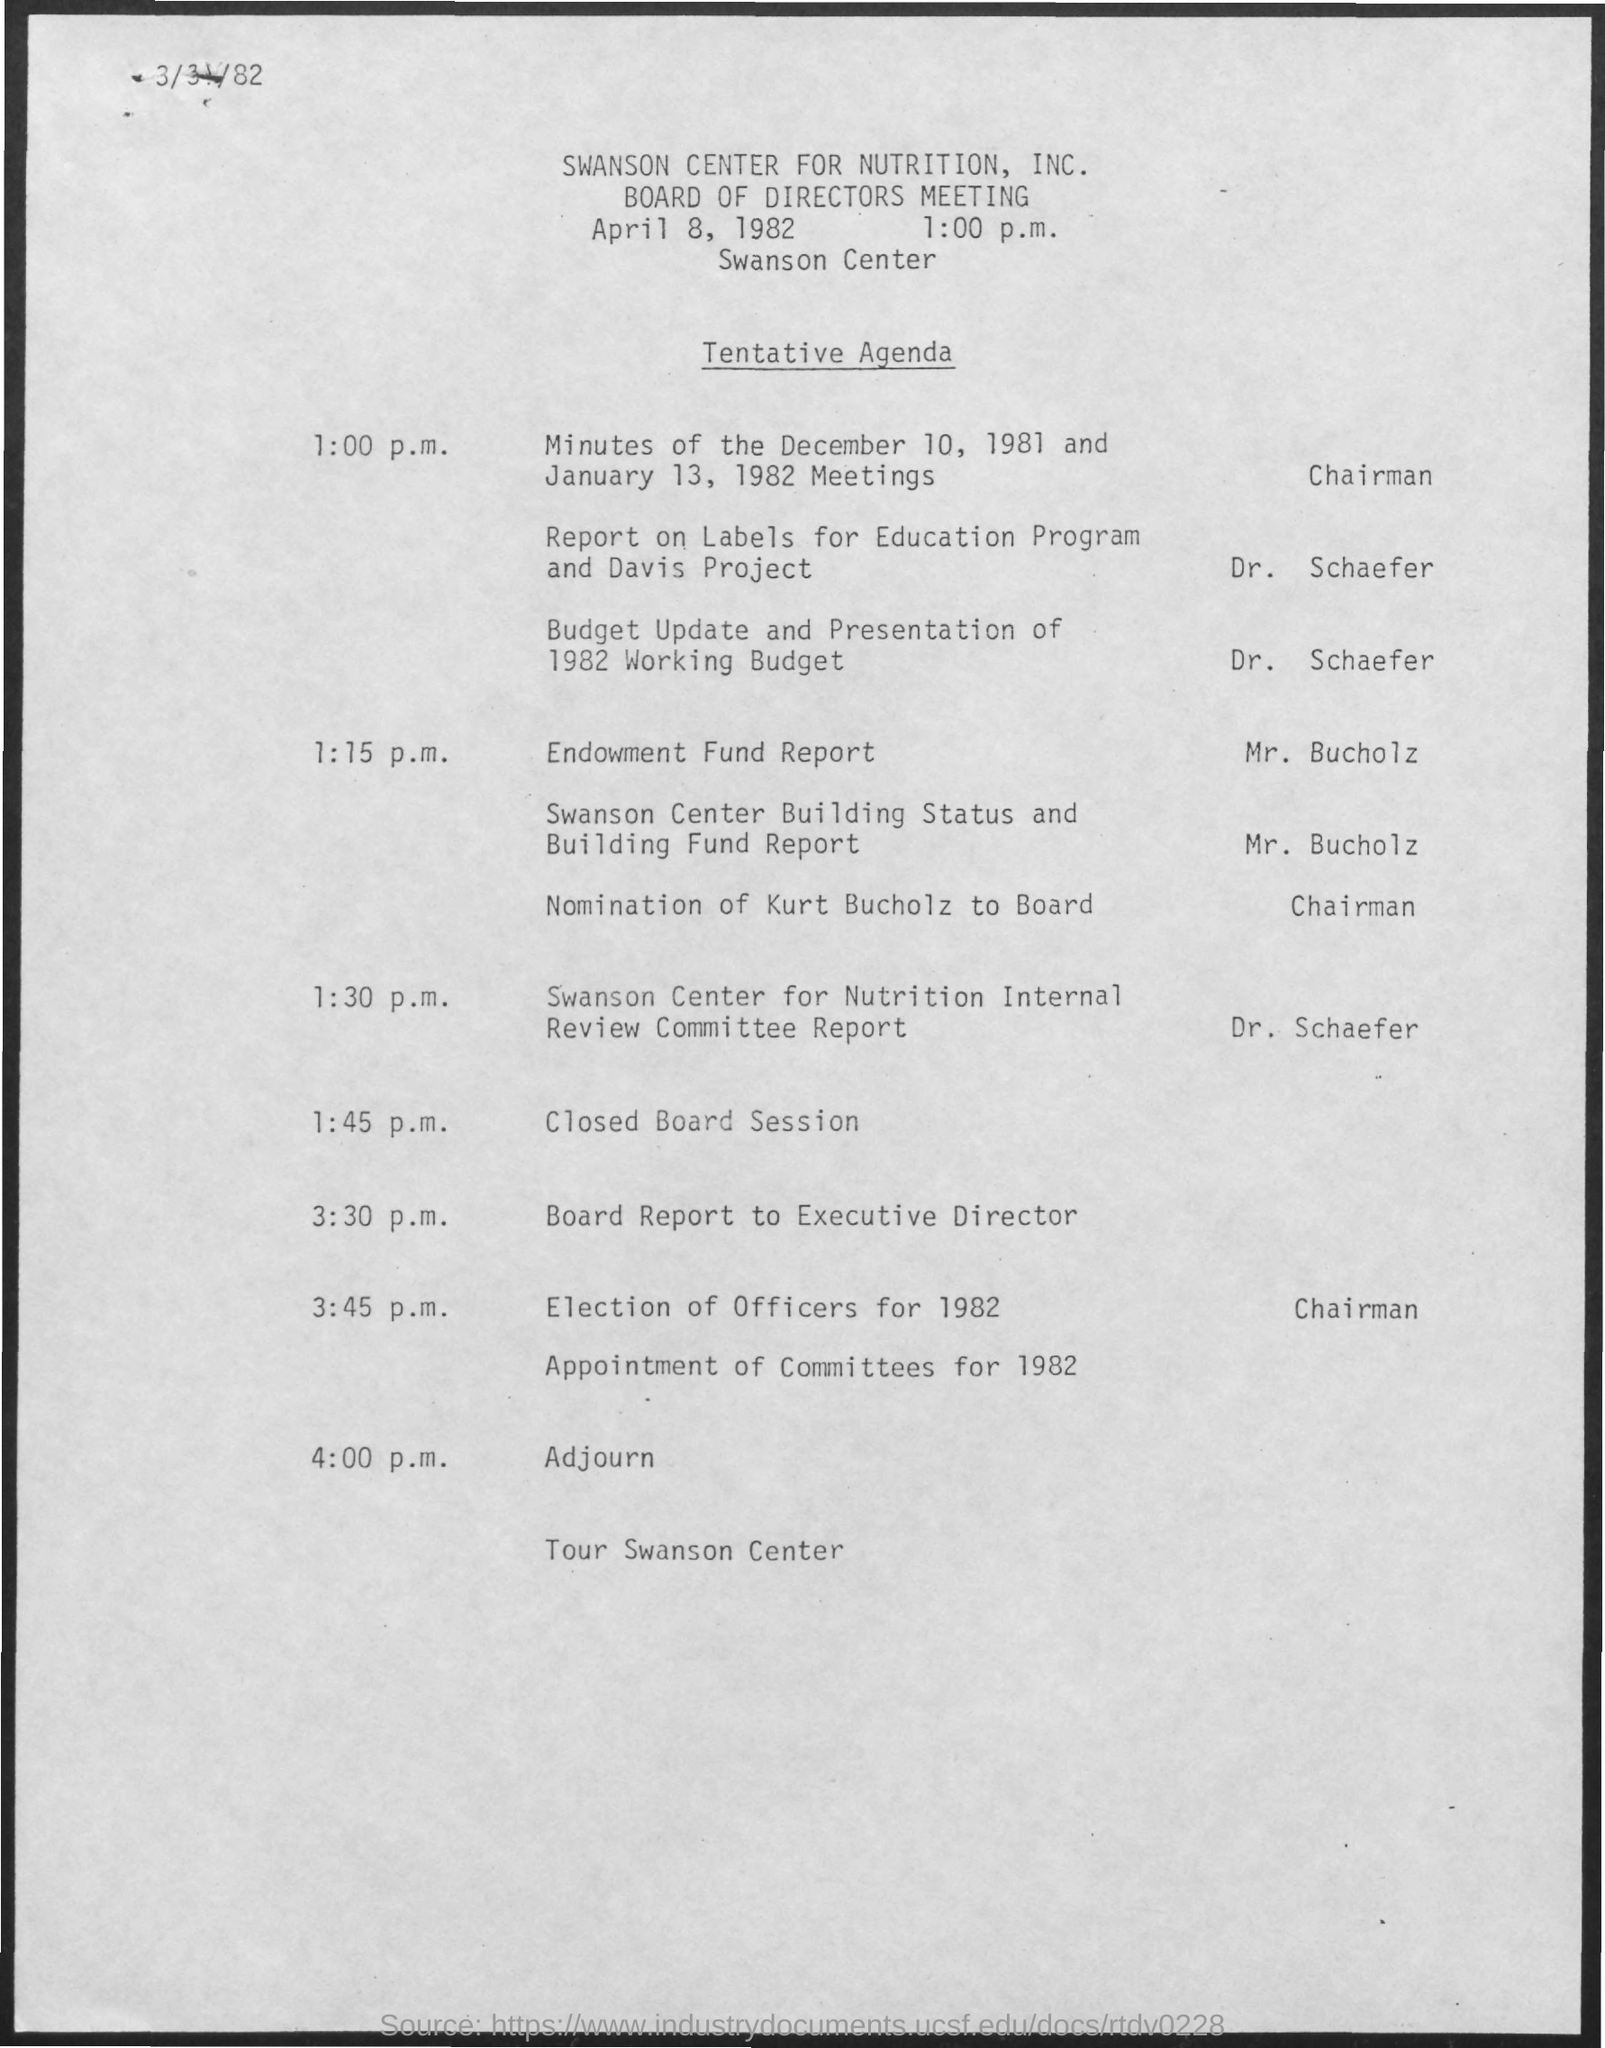List a handful of essential elements in this visual. The Endowment Fund Report will be presented by Mr. Bucholz. The meeting will take place at the Swanson Center. The Election of Officers for 1982 is scheduled to take place at 3:45 p.m. The board of directors' meeting will take place on April 8, 1982 at 1:00 p.m. 